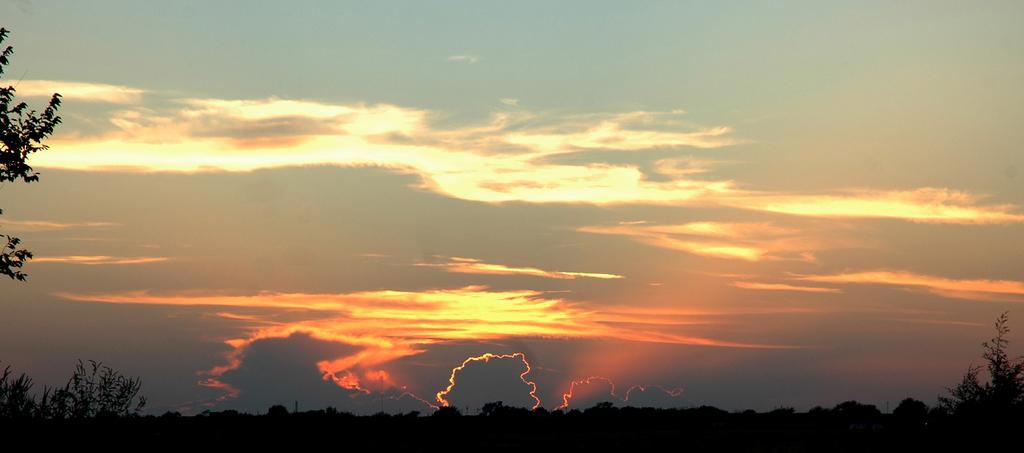Where was the image taken? The image was clicked outside the city. What can be seen in the foreground of the image? There are plants and trees in the foreground of the image. Can you describe the tree in the left corner of the image? Yes, there is a tree in the left corner of the image. What is visible in the background of the image? There is a sky visible in the background of the image. What can be observed in the sky? Clouds are present in the sky. What type of rail can be seen on the ground in the image? There is no rail present on the ground in the image. 